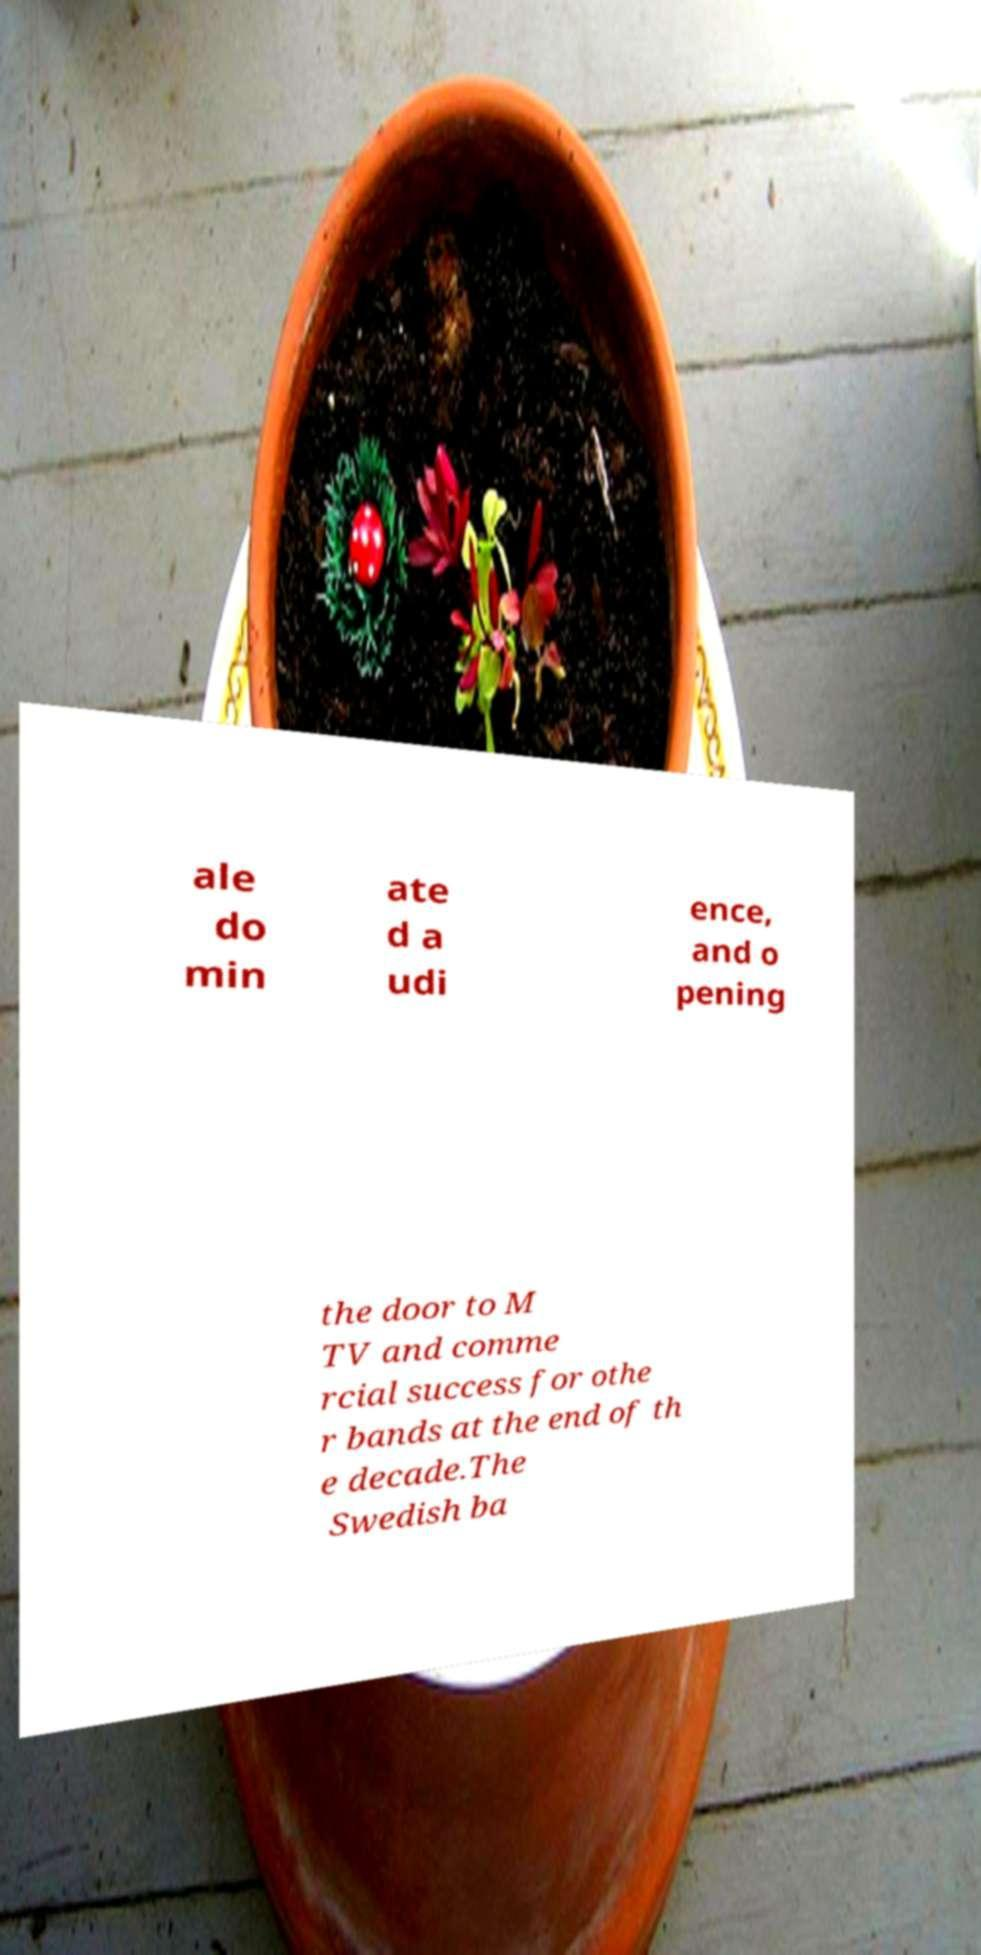Could you extract and type out the text from this image? ale do min ate d a udi ence, and o pening the door to M TV and comme rcial success for othe r bands at the end of th e decade.The Swedish ba 